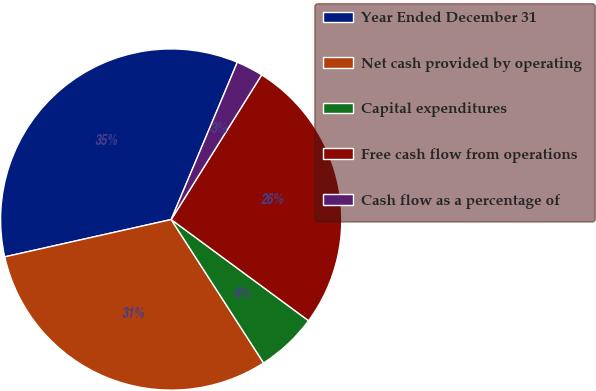Convert chart. <chart><loc_0><loc_0><loc_500><loc_500><pie_chart><fcel>Year Ended December 31<fcel>Net cash provided by operating<fcel>Capital expenditures<fcel>Free cash flow from operations<fcel>Cash flow as a percentage of<nl><fcel>34.85%<fcel>30.6%<fcel>5.79%<fcel>26.21%<fcel>2.56%<nl></chart> 